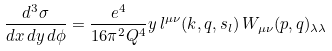<formula> <loc_0><loc_0><loc_500><loc_500>\frac { d ^ { 3 } \sigma } { d x \, d y \, d \phi } = \frac { e ^ { 4 } } { 1 6 \pi ^ { 2 } Q ^ { 4 } } y \, l ^ { \mu \nu } ( k , q , s _ { l } ) \, W _ { \mu \nu } ( p , q ) _ { \lambda \lambda }</formula> 